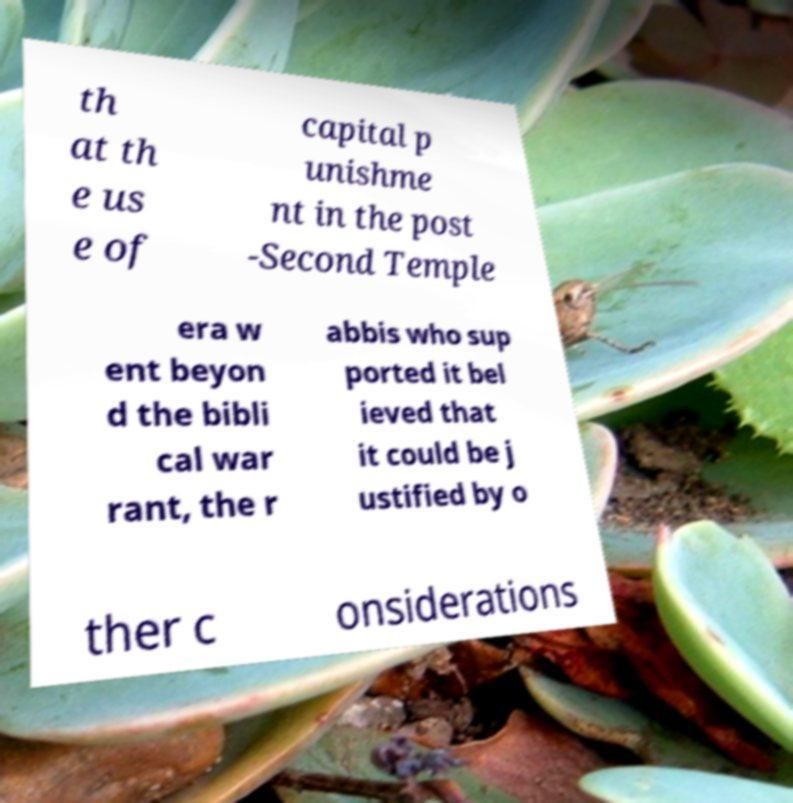Please read and relay the text visible in this image. What does it say? th at th e us e of capital p unishme nt in the post -Second Temple era w ent beyon d the bibli cal war rant, the r abbis who sup ported it bel ieved that it could be j ustified by o ther c onsiderations 